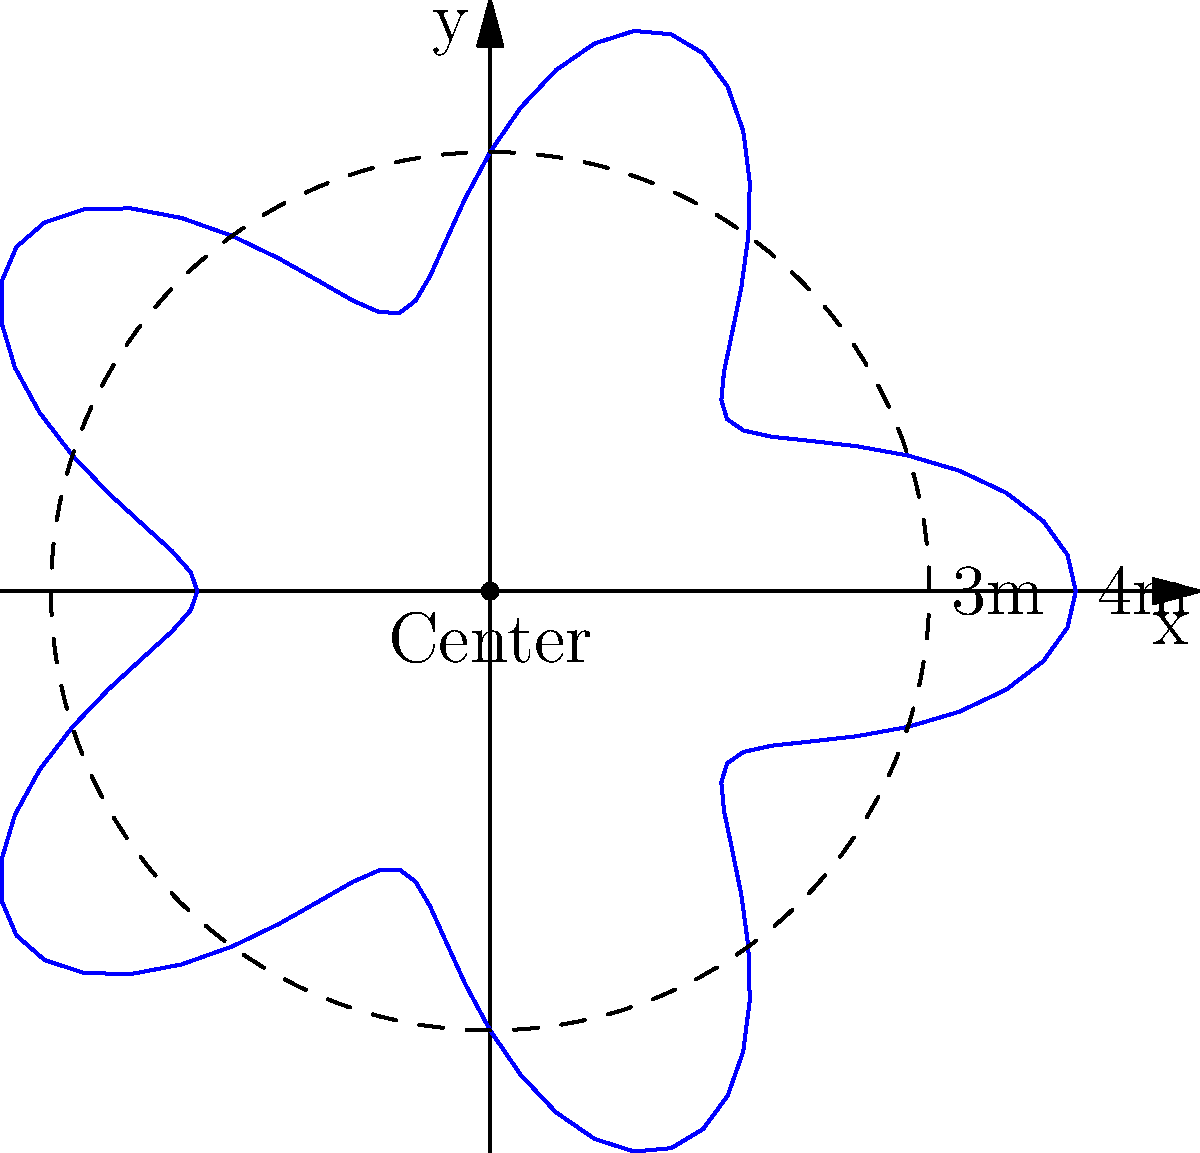A defensive player's court coverage is represented by the polar graph $r = 3 + \cos(5\theta)$, where $r$ is in meters. What is the maximum distance the player can cover from their starting position at the center? To find the maximum distance the player can cover, we need to determine the maximum value of $r$ in the given polar equation.

1. The equation is given as $r = 3 + \cos(5\theta)$

2. We know that the cosine function oscillates between -1 and 1.

3. The maximum value of $\cos(5\theta)$ is 1.

4. Therefore, the maximum value of $r$ occurs when $\cos(5\theta) = 1$:
   
   $r_{max} = 3 + 1 = 4$

5. This means the player can reach a maximum distance of 4 meters from their starting position at the center.

6. We can verify this visually from the graph, where the outermost point of the blue curve touches the 4m mark on the x-axis.
Answer: 4 meters 